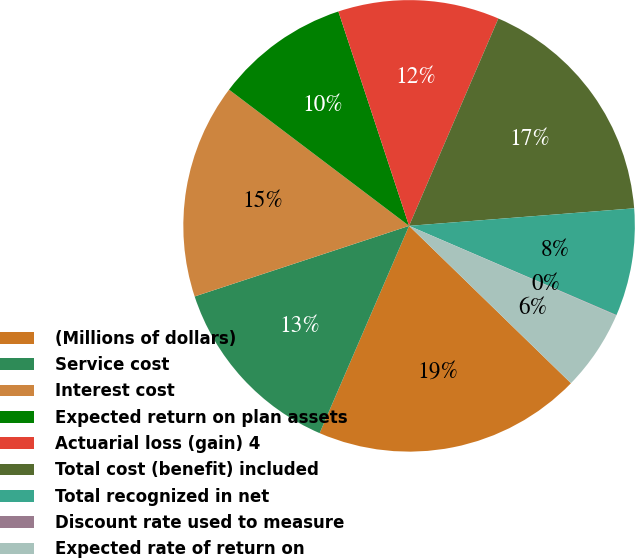<chart> <loc_0><loc_0><loc_500><loc_500><pie_chart><fcel>(Millions of dollars)<fcel>Service cost<fcel>Interest cost<fcel>Expected return on plan assets<fcel>Actuarial loss (gain) 4<fcel>Total cost (benefit) included<fcel>Total recognized in net<fcel>Discount rate used to measure<fcel>Expected rate of return on<nl><fcel>19.21%<fcel>13.45%<fcel>15.37%<fcel>9.62%<fcel>11.54%<fcel>17.29%<fcel>7.7%<fcel>0.03%<fcel>5.78%<nl></chart> 